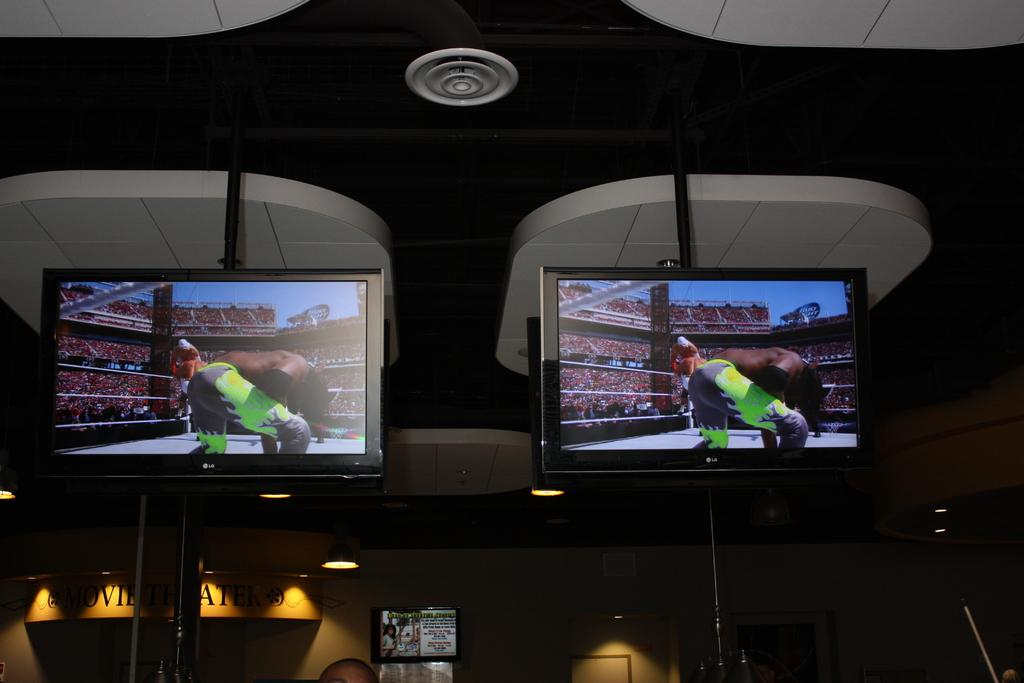Provide a one-sentence caption for the provided image. Two LG branded televisions are hung from the ceiling are seen displaying pro wrestling on their screens. 